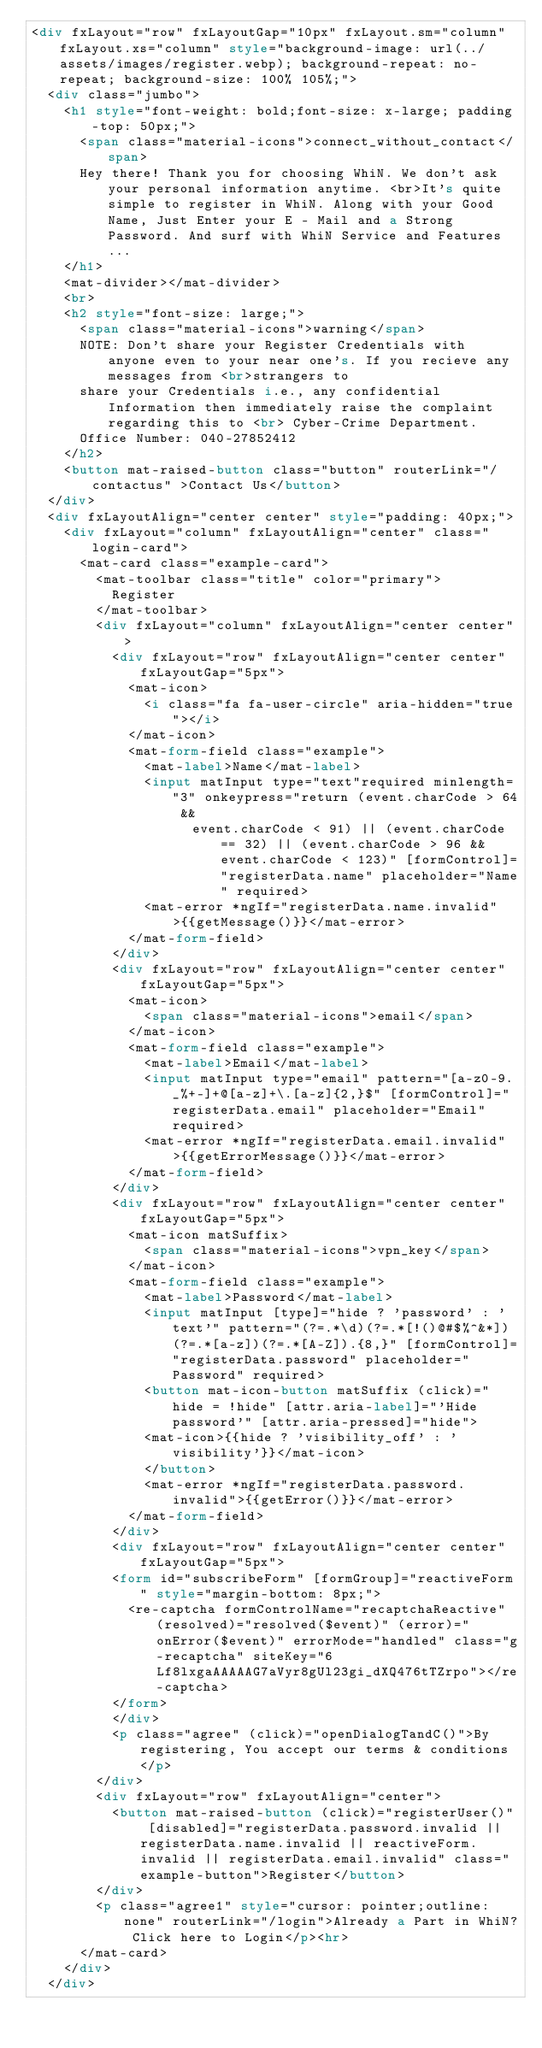<code> <loc_0><loc_0><loc_500><loc_500><_HTML_><div fxLayout="row" fxLayoutGap="10px" fxLayout.sm="column" fxLayout.xs="column" style="background-image: url(../assets/images/register.webp); background-repeat: no-repeat; background-size: 100% 105%;">
  <div class="jumbo">
    <h1 style="font-weight: bold;font-size: x-large; padding-top: 50px;">
      <span class="material-icons">connect_without_contact</span>
      Hey there! Thank you for choosing WhiN. We don't ask your personal information anytime. <br>It's quite simple to register in WhiN. Along with your Good Name, Just Enter your E - Mail and a Strong Password. And surf with WhiN Service and Features...
    </h1>
    <mat-divider></mat-divider>
    <br>
    <h2 style="font-size: large;">
      <span class="material-icons">warning</span>
      NOTE: Don't share your Register Credentials with anyone even to your near one's. If you recieve any messages from <br>strangers to 
      share your Credentials i.e., any confidential Information then immediately raise the complaint regarding this to <br> Cyber-Crime Department.
      Office Number: 040-27852412
    </h2>
    <button mat-raised-button class="button" routerLink="/contactus" >Contact Us</button>
  </div>
  <div fxLayoutAlign="center center" style="padding: 40px;">
    <div fxLayout="column" fxLayoutAlign="center" class="login-card">
      <mat-card class="example-card">
        <mat-toolbar class="title" color="primary">
          Register
        </mat-toolbar>
        <div fxLayout="column" fxLayoutAlign="center center">
          <div fxLayout="row" fxLayoutAlign="center center" fxLayoutGap="5px">
            <mat-icon>
              <i class="fa fa-user-circle" aria-hidden="true"></i>
            </mat-icon>
            <mat-form-field class="example">
              <mat-label>Name</mat-label>
              <input matInput type="text"required minlength="3" onkeypress="return (event.charCode > 64 && 
                    event.charCode < 91) || (event.charCode == 32) || (event.charCode > 96 && event.charCode < 123)" [formControl]="registerData.name" placeholder="Name" required>
              <mat-error *ngIf="registerData.name.invalid">{{getMessage()}}</mat-error>
            </mat-form-field>
          </div>
          <div fxLayout="row" fxLayoutAlign="center center" fxLayoutGap="5px">
            <mat-icon>
              <span class="material-icons">email</span>
            </mat-icon>
            <mat-form-field class="example">
              <mat-label>Email</mat-label>
              <input matInput type="email" pattern="[a-z0-9._%+-]+@[a-z]+\.[a-z]{2,}$" [formControl]="registerData.email" placeholder="Email" required>
              <mat-error *ngIf="registerData.email.invalid">{{getErrorMessage()}}</mat-error>
            </mat-form-field>
          </div>
          <div fxLayout="row" fxLayoutAlign="center center" fxLayoutGap="5px">
            <mat-icon matSuffix>
              <span class="material-icons">vpn_key</span>
            </mat-icon>
            <mat-form-field class="example">
              <mat-label>Password</mat-label>
              <input matInput [type]="hide ? 'password' : 'text'" pattern="(?=.*\d)(?=.*[!()@#$%^&*])(?=.*[a-z])(?=.*[A-Z]).{8,}" [formControl]="registerData.password" placeholder="Password" required> 
              <button mat-icon-button matSuffix (click)="hide = !hide" [attr.aria-label]="'Hide password'" [attr.aria-pressed]="hide">
              <mat-icon>{{hide ? 'visibility_off' : 'visibility'}}</mat-icon>
              </button>
              <mat-error *ngIf="registerData.password.invalid">{{getError()}}</mat-error>
            </mat-form-field>
          </div>
          <div fxLayout="row" fxLayoutAlign="center center" fxLayoutGap="5px">
          <form id="subscribeForm" [formGroup]="reactiveForm" style="margin-bottom: 8px;">
            <re-captcha formControlName="recaptchaReactive" (resolved)="resolved($event)" (error)="onError($event)" errorMode="handled" class="g-recaptcha" siteKey="6Lf8lxgaAAAAAG7aVyr8gUl23gi_dXQ476tTZrpo"></re-captcha>
          </form>
          </div>
          <p class="agree" (click)="openDialogTandC()">By registering, You accept our terms & conditions</p>
        </div>
        <div fxLayout="row" fxLayoutAlign="center">
          <button mat-raised-button (click)="registerUser()" [disabled]="registerData.password.invalid || registerData.name.invalid || reactiveForm.invalid || registerData.email.invalid" class="example-button">Register</button>
        </div>
        <p class="agree1" style="cursor: pointer;outline:none" routerLink="/login">Already a Part in WhiN? Click here to Login</p><hr>
      </mat-card>
    </div>
  </div></code> 